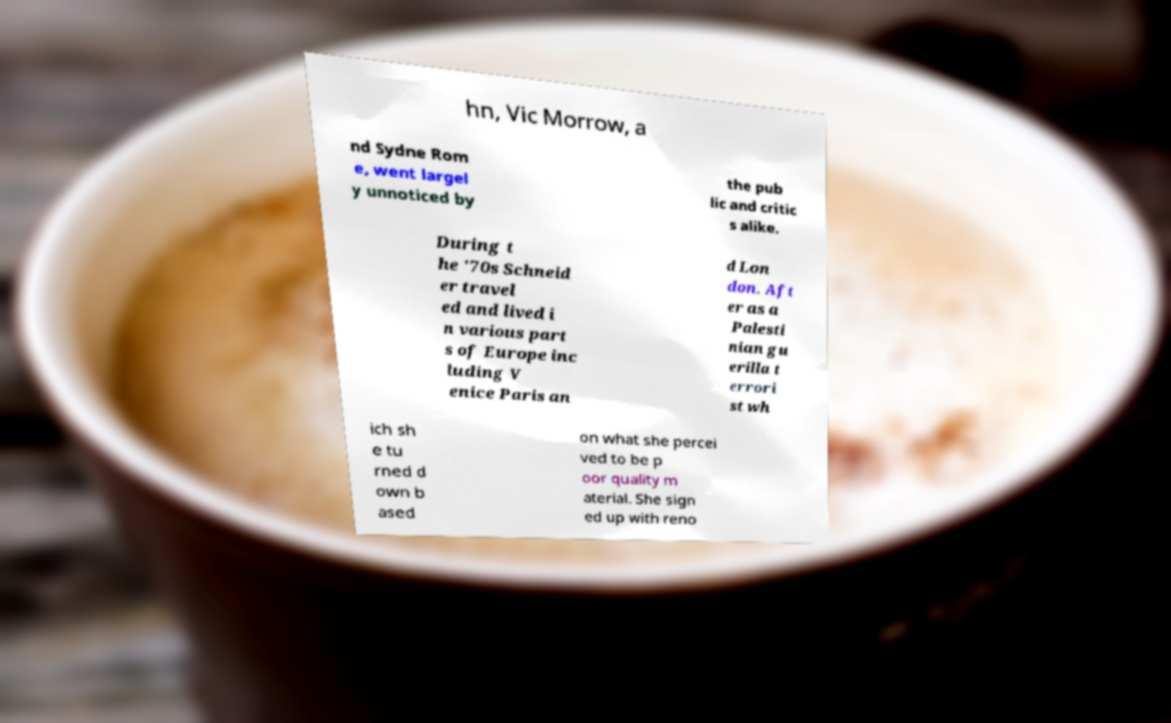There's text embedded in this image that I need extracted. Can you transcribe it verbatim? hn, Vic Morrow, a nd Sydne Rom e, went largel y unnoticed by the pub lic and critic s alike. During t he '70s Schneid er travel ed and lived i n various part s of Europe inc luding V enice Paris an d Lon don. Aft er as a Palesti nian gu erilla t errori st wh ich sh e tu rned d own b ased on what she percei ved to be p oor quality m aterial. She sign ed up with reno 